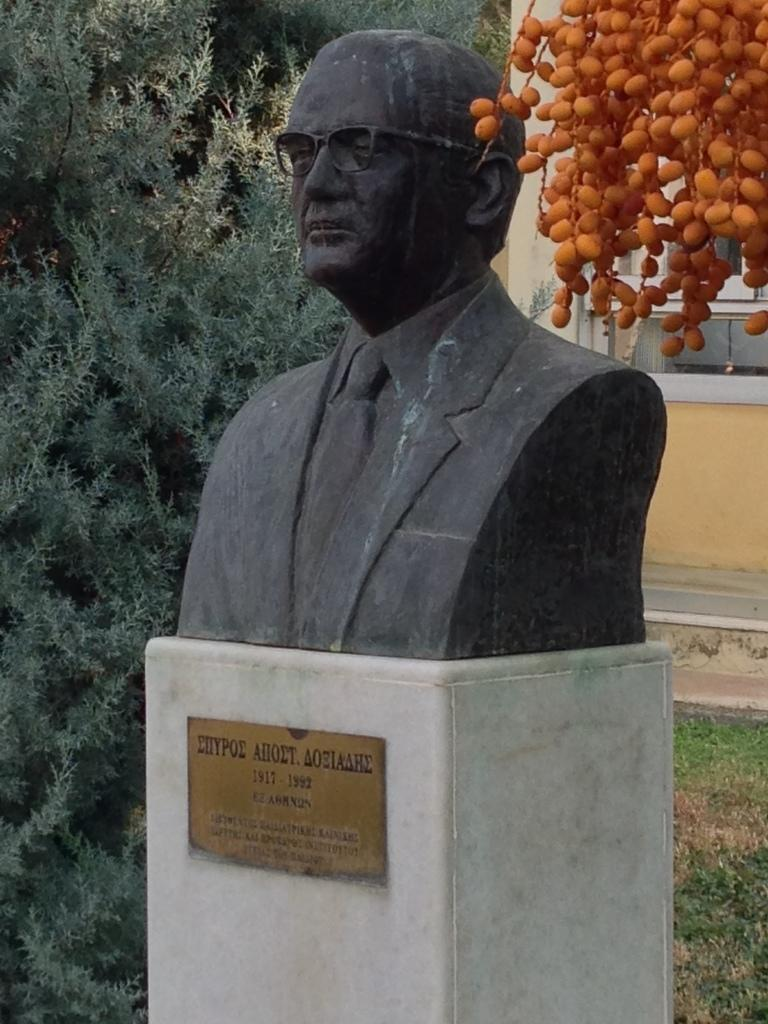What is the main subject in the image? There is a statue in the image. Is there any text or identification associated with the statue? Yes, there is a name board in the image. What can be seen in the background of the image? There are trees in the background of the image. What type of ground is visible at the bottom of the image? There is green grass at the bottom of the image. What type of snake can be seen slithering around the statue in the image? There is no snake present in the image; it only features a statue and a name board. 